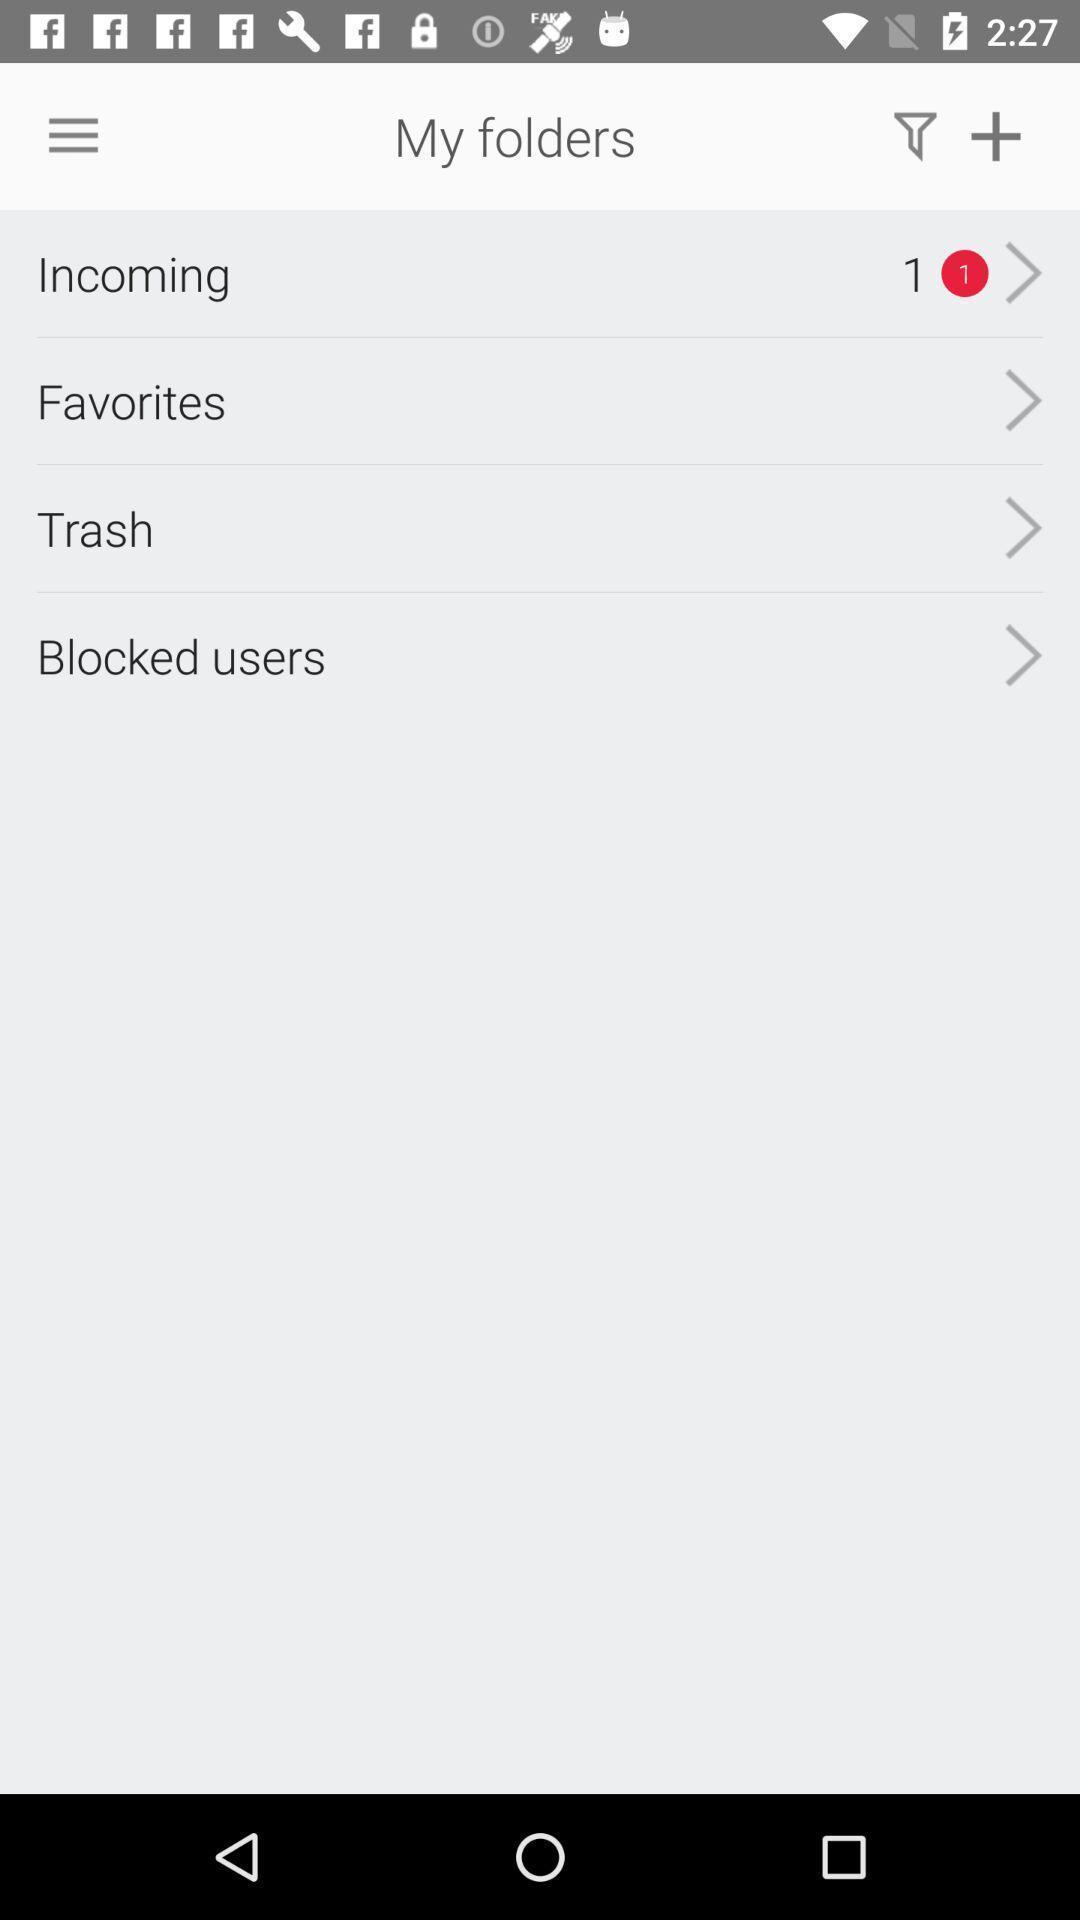Describe this image in words. Page showing the option in my folders tab. 